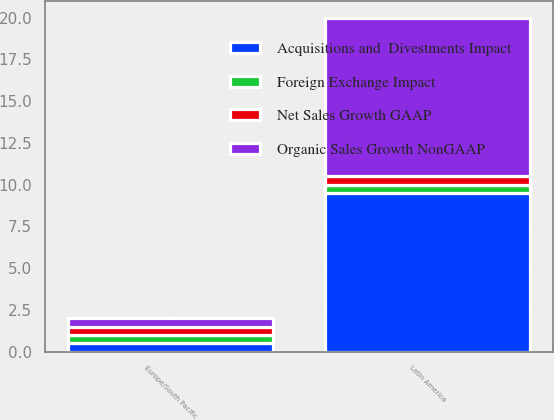Convert chart to OTSL. <chart><loc_0><loc_0><loc_500><loc_500><stacked_bar_chart><ecel><fcel>Latin America<fcel>Europe/South Pacific<nl><fcel>Acquisitions and  Divestments Impact<fcel>9.5<fcel>0.5<nl><fcel>Organic Sales Growth NonGAAP<fcel>9.5<fcel>0.5<nl><fcel>Net Sales Growth GAAP<fcel>0.5<fcel>0.5<nl><fcel>Foreign Exchange Impact<fcel>0.5<fcel>0.5<nl></chart> 